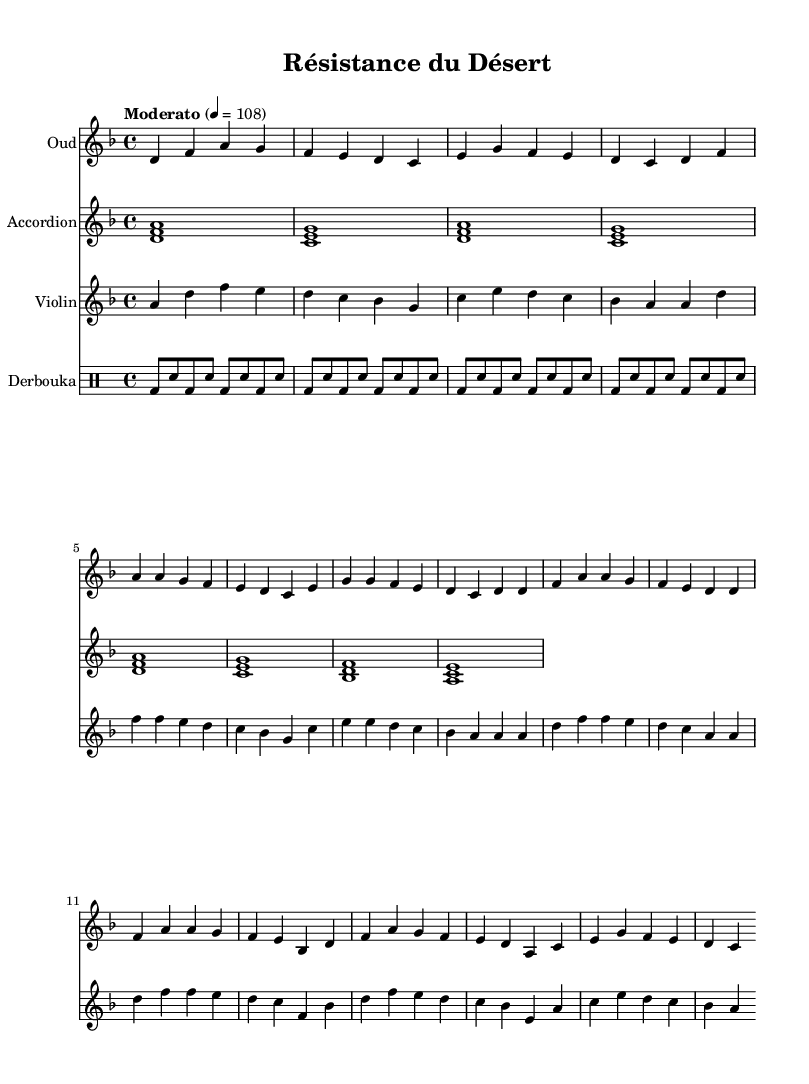What is the key signature of this music? The key signature indicates that the piece is in D minor, which includes one flat (B flat). This can be observed in the initial section of the score where the key is specified.
Answer: D minor What is the time signature of this music? The time signature is shown at the beginning of the piece and is notated as 4/4, meaning there are four beats in each measure. This is clear from the notation placed at the start of the score.
Answer: 4/4 What is the tempo marking of the music? The tempo marking is specified in the score as "Moderato" with a metronome marking of quarter note equals 108 BPM. This can be found alongside the key and time signature at the beginning of the sheet music.
Answer: Moderato, 108 How many measures are in the Oud part? By counting the individual sections and looking at the line breaks in the staff for the Oud part, we can determine that there are eight measures in total. Each measure is divided clearly, allowing for straightforward counting.
Answer: 8 Which instruments are included in the score? The instruments can be identified at the beginning of each staff. There are four parts: Oud, Accordion, Violin, and Derbouka, as labeled clearly at the start of each corresponding staff.
Answer: Oud, Accordion, Violin, Derbouka What rhythmic pattern does the Derbouka play? The Derbouka does notate a repeating pattern of bass and snare drum hits, alternately creating a standard rhythm commonly found in North African music. This pattern consists of bass and snare hits repeated over four measures.
Answer: Bass and snare pattern What is the role of the violin in this piece? The violin provides a melodic line that complements the harmonic structure established by the Oud and the Accordion. The distinctive melodic sequences and phrases make it pivotal in enhancing the overall musical texture.
Answer: Melodic line 